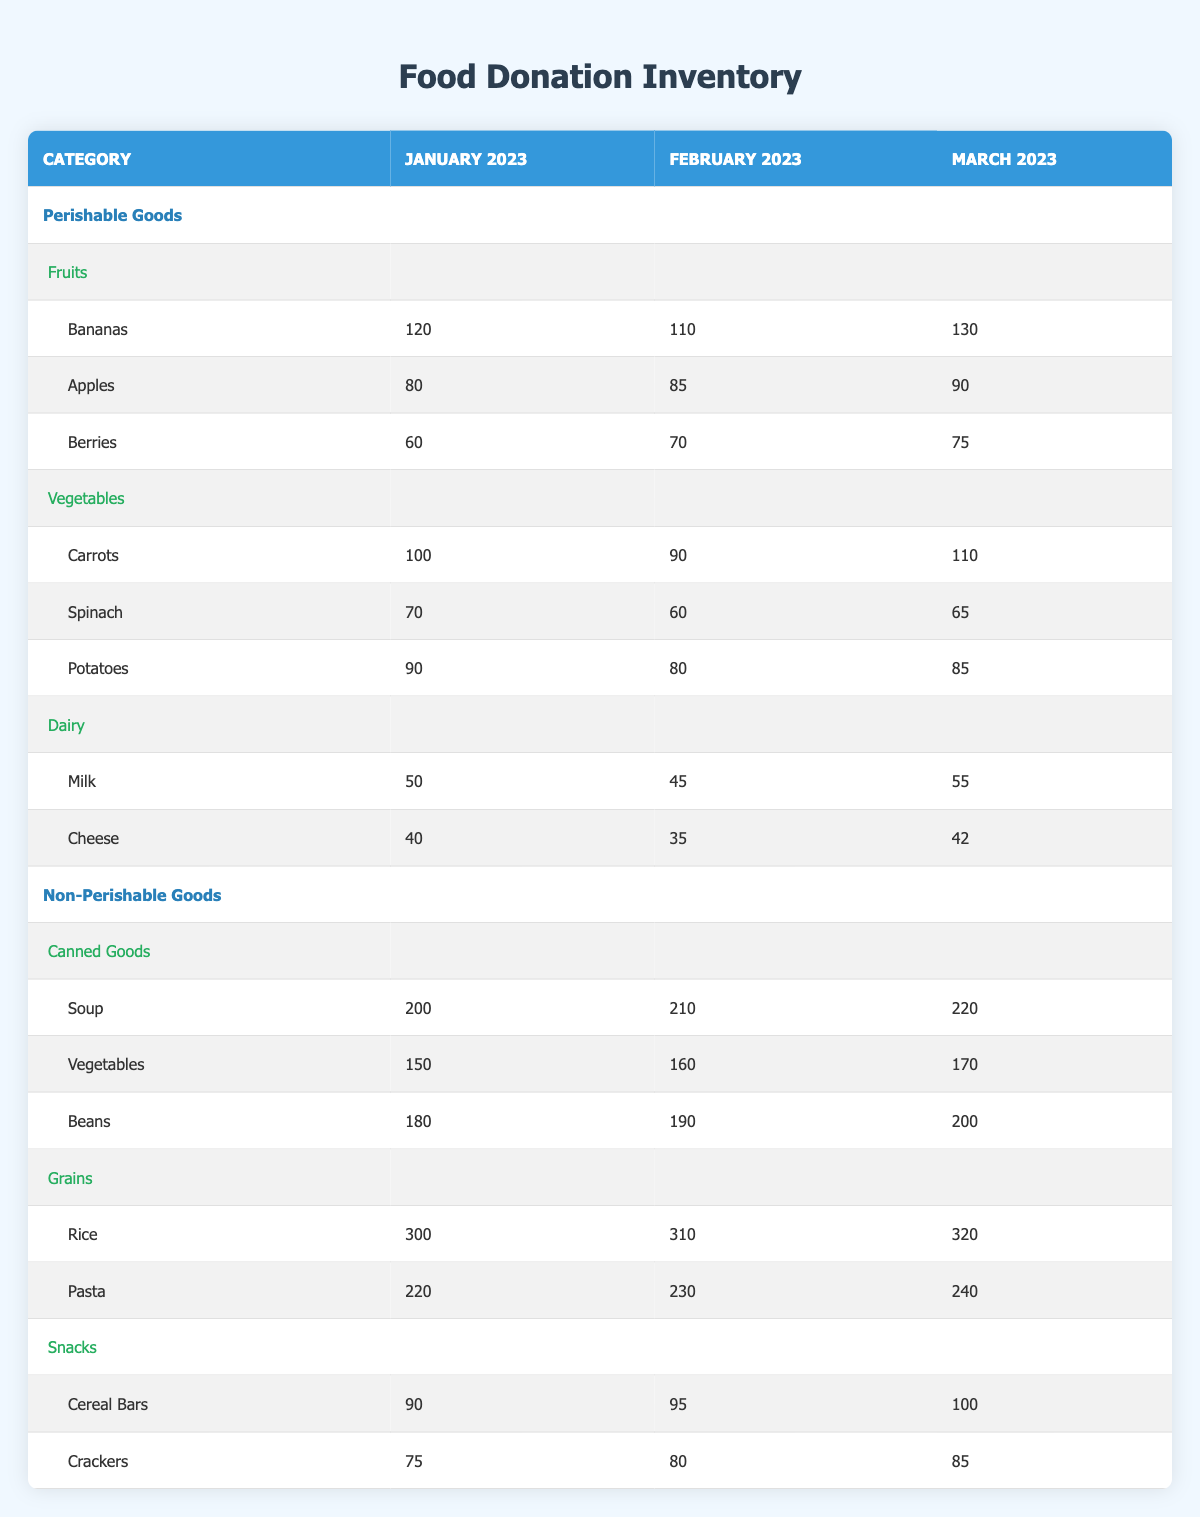What was the total amount of perishable goods donated in January 2023? To find the total amount of perishable goods, we need to sum the donations for fruits, vegetables, and dairy in January 2023. The totals are: fruits (120 + 80 + 60 = 260), vegetables (100 + 70 + 90 = 260), and dairy (50 + 40 = 90). Thus, the total is 260 + 260 + 90 = 610.
Answer: 610 Which month had the highest donation of canned goods? The canned goods donations for the months are: January 2023 (200), February 2023 (210), and March 2023 (220). March 2023 had the highest donation at 220.
Answer: March 2023 Did the donation of apples increase, decrease, or remain the same from January to March 2023? The donation amounts for apples were: January 2023 (80), February 2023 (85), and March 2023 (90). The amounts show an increase from January to February and from February to March, indicating a consistent increase.
Answer: Increase What was the average donation of rice over the three months? To find the average donation of rice, we need the amounts for each month: January (300), February (310), and March (320). First, we add the amounts: 300 + 310 + 320 = 930. Then, we divide by the number of months, which is 3. So, 930 / 3 = 310.
Answer: 310 How many more beans were donated in March compared to January? The donation amounts for beans were: January 2023 (180) and March 2023 (200). To find the difference, we subtract the January amount from the March amount: 200 - 180 = 20.
Answer: 20 Which type of dairy product had the highest donation in February 2023? The donations for dairy in February 2023 are: milk (45) and cheese (35). Since 45 (milk) is greater than 35 (cheese), milk had the highest donation in February.
Answer: Milk Did the total amount of non-perishable goods increase from February to March 2023? For February 2023, we sum the non-perishable goods: canned goods (210 + 160 + 190 = 560), grains (310 + 230 = 540), and snacks (95 + 80 = 175). Total for February is 560 + 540 + 175 = 1275. For March 2023, we calculate again: canned goods (220 + 170 + 200 = 590), grains (320 + 240 = 560), and snacks (100 + 85 = 185). Total for March is 590 + 560 + 185 = 1335. Since 1335 is greater than 1275, there was indeed an increase.
Answer: Yes What is the total amount of fruits donated over the three months? To get the total amount for fruits, we sum the donations for January, February, and March: January (120 + 80 + 60 = 260), February (110 + 85 + 70 = 265), and March (130 + 90 + 75 = 295). Summing these totals gives us 260 + 265 + 295 = 820.
Answer: 820 